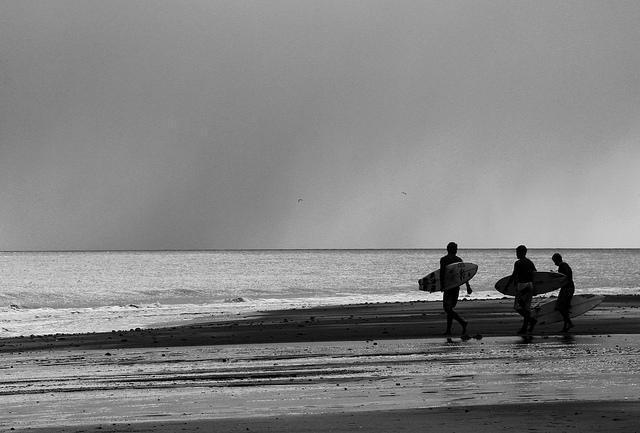How many people aren't riding horses in this picture?
Give a very brief answer. 3. 